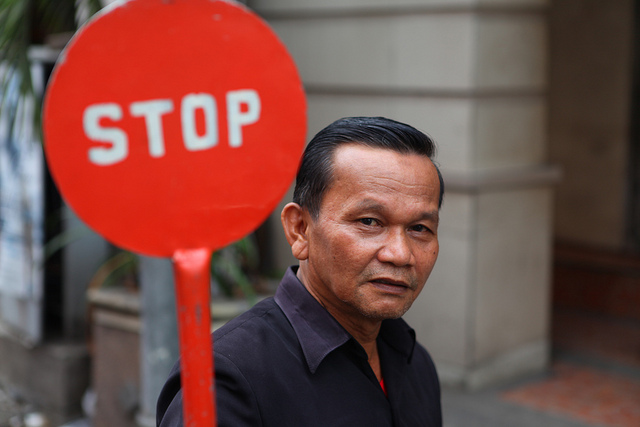Identify and read out the text in this image. STOP 